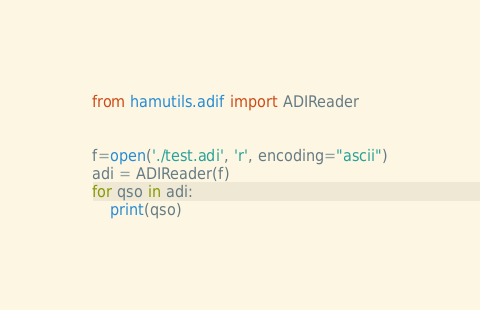<code> <loc_0><loc_0><loc_500><loc_500><_Python_>from hamutils.adif import ADIReader


f=open('./test.adi', 'r', encoding="ascii")
adi = ADIReader(f)
for qso in adi:
    print(qso)
</code> 